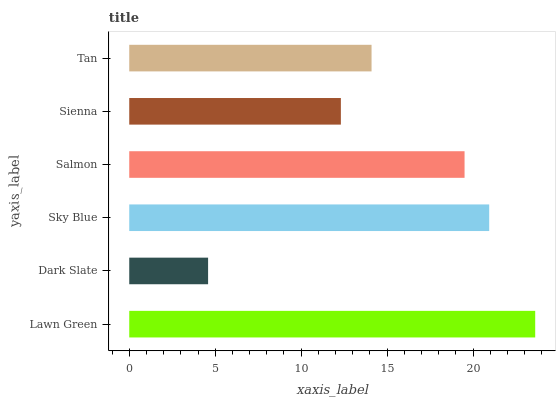Is Dark Slate the minimum?
Answer yes or no. Yes. Is Lawn Green the maximum?
Answer yes or no. Yes. Is Sky Blue the minimum?
Answer yes or no. No. Is Sky Blue the maximum?
Answer yes or no. No. Is Sky Blue greater than Dark Slate?
Answer yes or no. Yes. Is Dark Slate less than Sky Blue?
Answer yes or no. Yes. Is Dark Slate greater than Sky Blue?
Answer yes or no. No. Is Sky Blue less than Dark Slate?
Answer yes or no. No. Is Salmon the high median?
Answer yes or no. Yes. Is Tan the low median?
Answer yes or no. Yes. Is Tan the high median?
Answer yes or no. No. Is Lawn Green the low median?
Answer yes or no. No. 